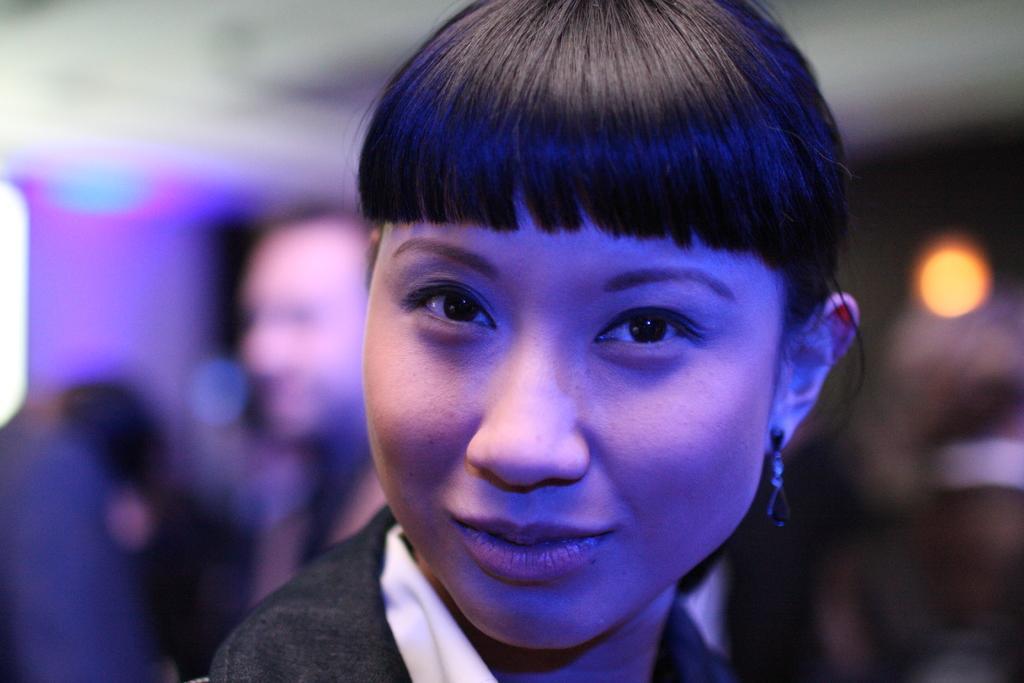Describe this image in one or two sentences. A beautiful woman is looking at this, she wore black color top. 